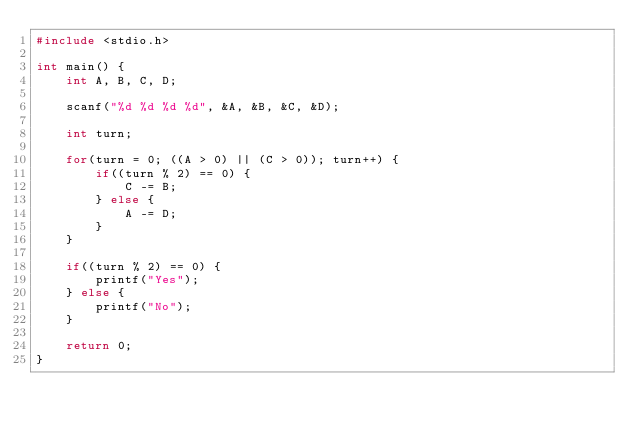Convert code to text. <code><loc_0><loc_0><loc_500><loc_500><_C_>#include <stdio.h>

int main() {
    int A, B, C, D;
    
    scanf("%d %d %d %d", &A, &B, &C, &D);

    int turn;

    for(turn = 0; ((A > 0) || (C > 0)); turn++) {
        if((turn % 2) == 0) {
            C -= B;
        } else {
            A -= D;
        }
    }

    if((turn % 2) == 0) {
        printf("Yes");
    } else {
        printf("No");
    }

    return 0;
}</code> 